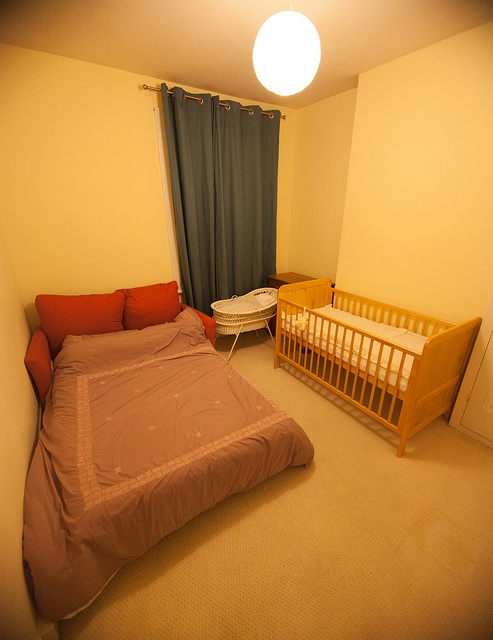Describe the objects in this image and their specific colors. I can see bed in black, brown, maroon, and red tones and bed in black, red, and orange tones in this image. 